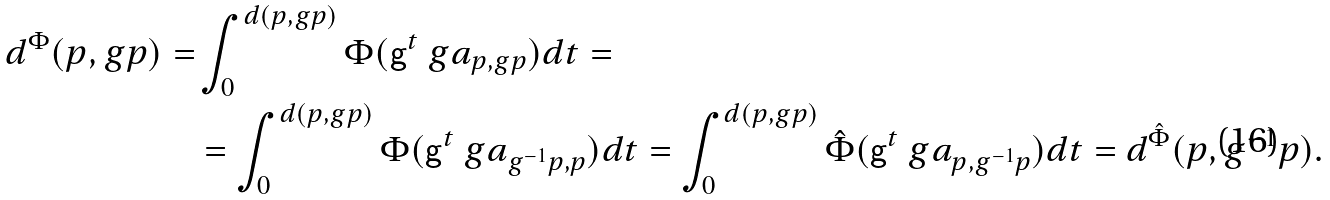<formula> <loc_0><loc_0><loc_500><loc_500>d ^ { \Phi } ( p , g p ) = & \int _ { 0 } ^ { d ( p , g p ) } \Phi ( { \mathsf g } ^ { t } \ g a _ { p , g p } ) d t = \\ & = \int _ { 0 } ^ { d ( p , g p ) } \Phi ( { \mathsf g } ^ { t } \ g a _ { g ^ { - 1 } p , p } ) d t = \int _ { 0 } ^ { d ( p , g p ) } \hat { \Phi } ( { \mathsf g } ^ { t } \ g a _ { p , g ^ { - 1 } p } ) d t = d ^ { \hat { \Phi } } ( p , g ^ { - 1 } p ) .</formula> 